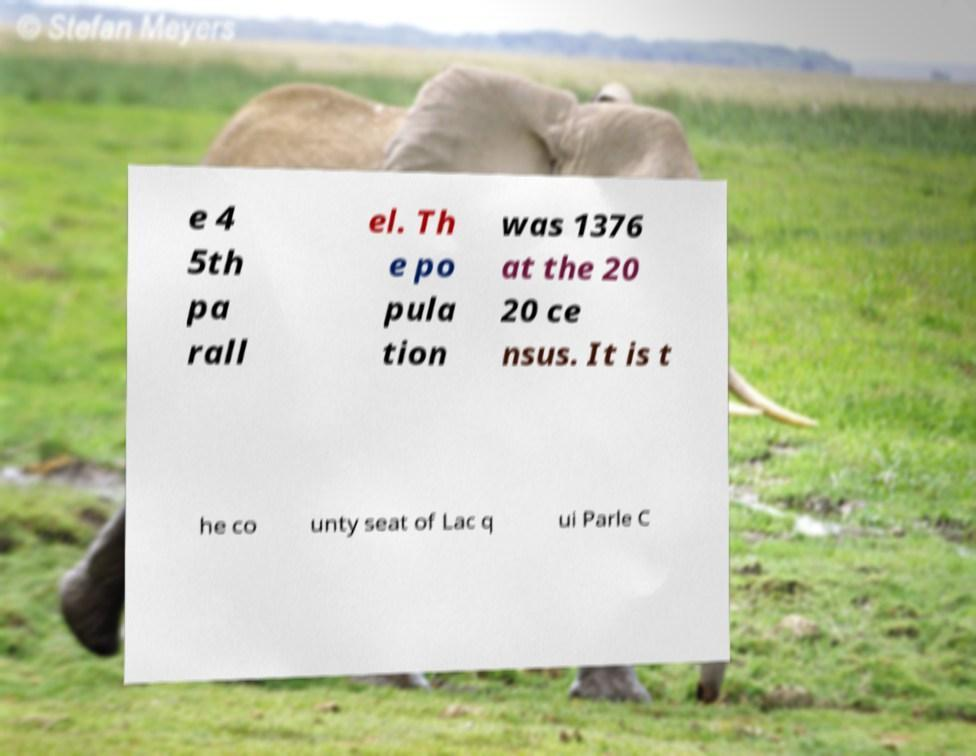What messages or text are displayed in this image? I need them in a readable, typed format. e 4 5th pa rall el. Th e po pula tion was 1376 at the 20 20 ce nsus. It is t he co unty seat of Lac q ui Parle C 